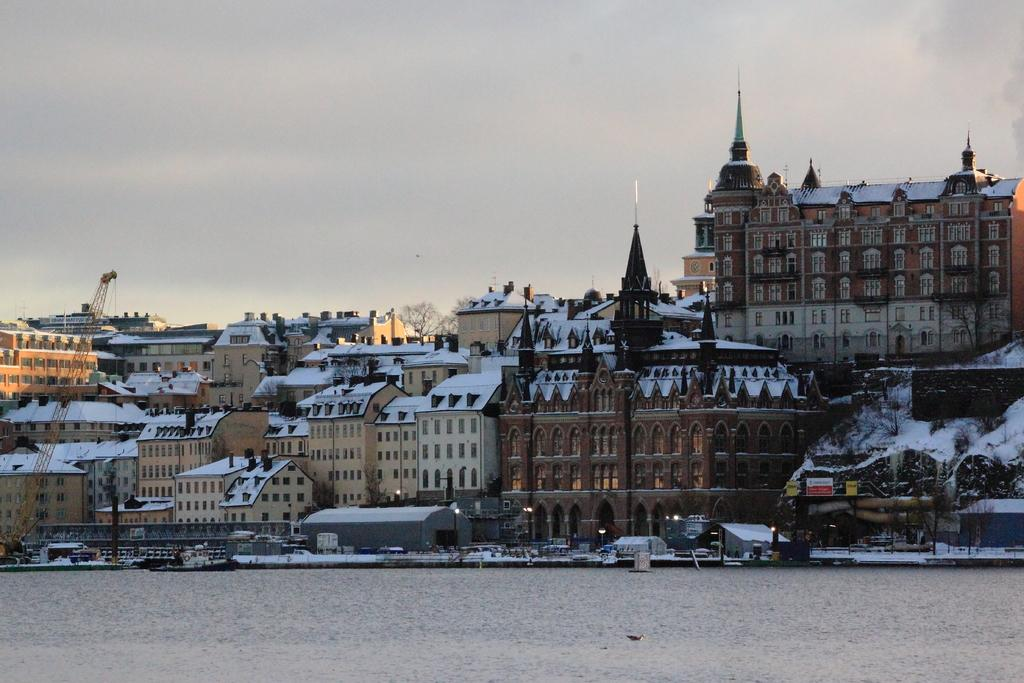What type of structures can be seen in the image? There are buildings and sheds in the image. What type of lighting is visible in the image? Electric lights are visible in the image. What type of transportation is present in the image? Motor vehicles are present in the image. What type of equipment is visible in the image? Construction cranes are in the image. What type of natural element is visible in the image? Water is visible in the image. What part of the natural environment is visible in the image? The sky is visible in the image. What type of treatment is being administered to the water in the image? There is no indication in the image that any treatment is being administered to the water. What is the existence of in the image? The question is too vague to answer definitively. Please provide more specific information about what you are referring to. 